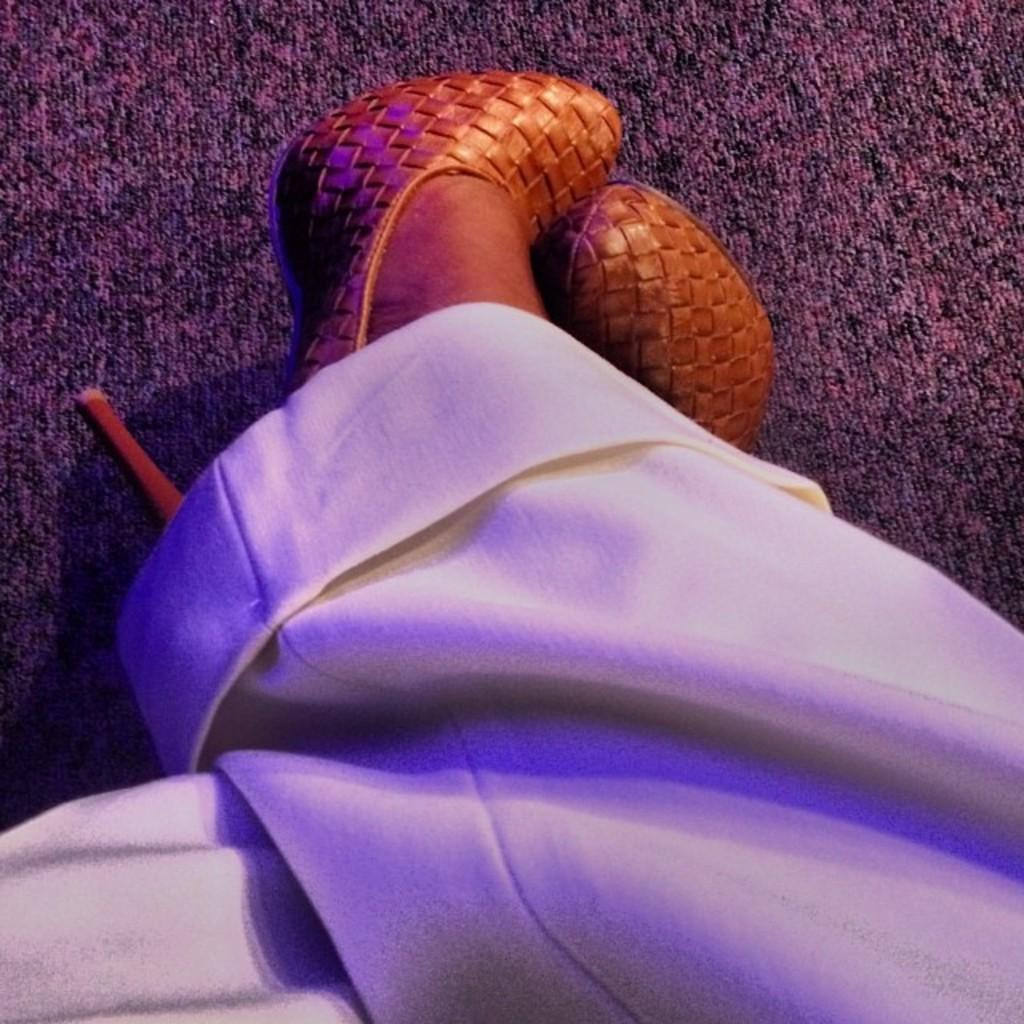What part of a woman's body can be seen in the image? The woman's legs are visible in the image. What color are the trousers the woman is wearing? The woman is wearing white-colored trousers. What type of footwear is the woman wearing? The woman is wearing golden-colored heels. What can be found on the floor in the image? There is a floor mat in the image. What type of mist can be seen surrounding the woman's legs in the image? There is no mist present in the image; the woman's legs are visible against a clear background. 